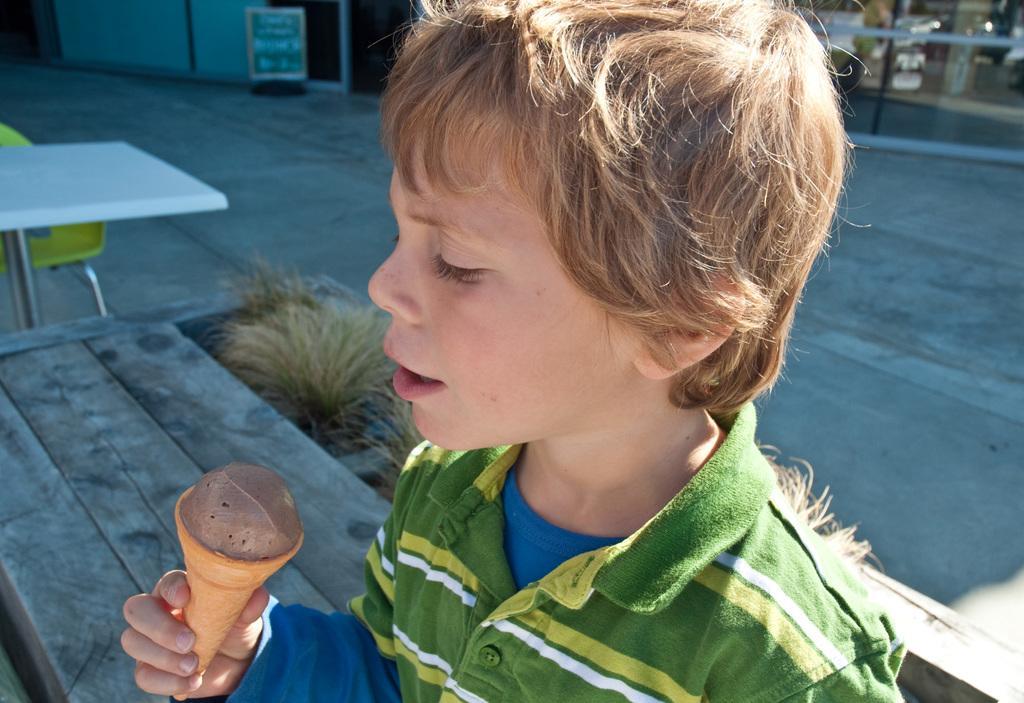Describe this image in one or two sentences. In the foreground this image, there is a boy holding an ice cream is sitting on the bench. We can also see the grass, table, chair, floor and the wall. 